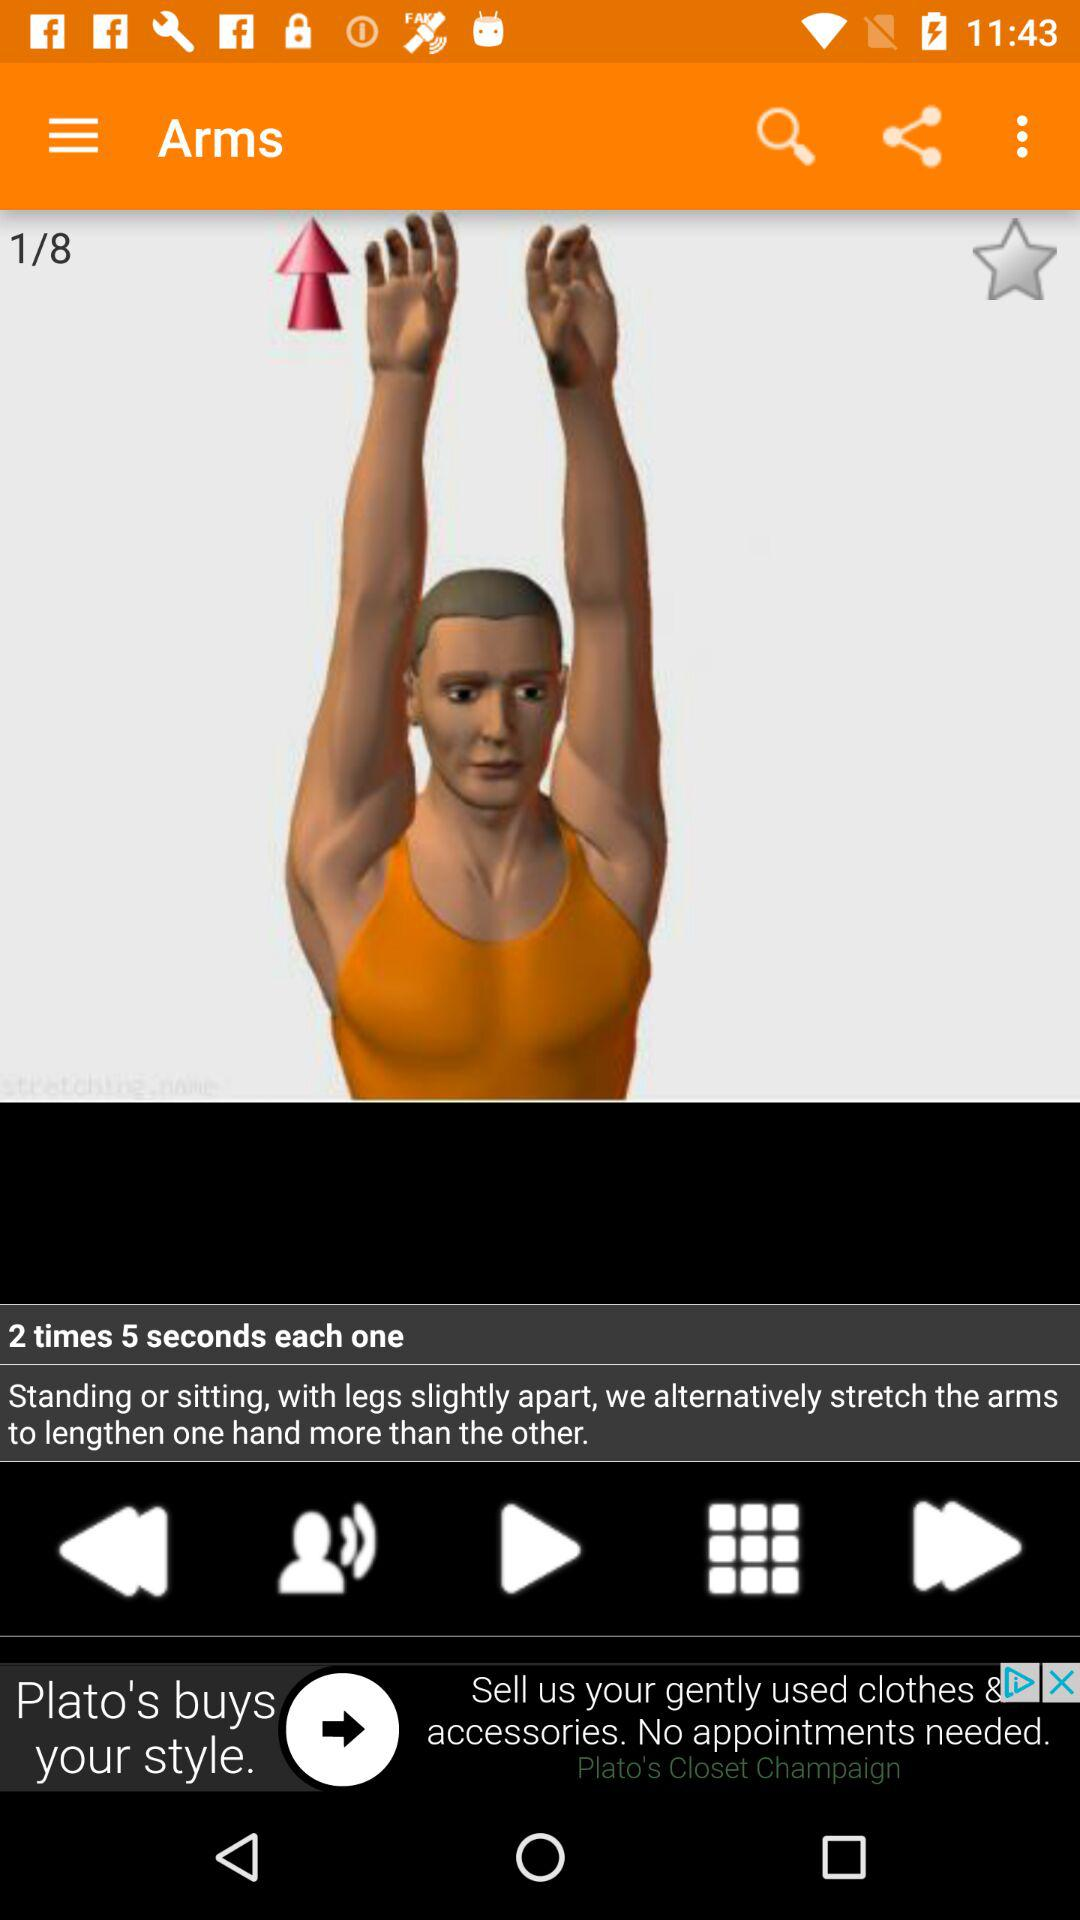How many calories does the arms exercise burn?
When the provided information is insufficient, respond with <no answer>. <no answer> 